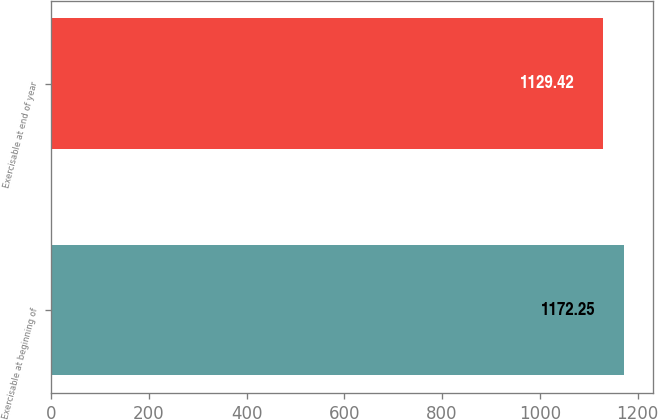Convert chart. <chart><loc_0><loc_0><loc_500><loc_500><bar_chart><fcel>Exercisable at beginning of<fcel>Exercisable at end of year<nl><fcel>1172.25<fcel>1129.42<nl></chart> 